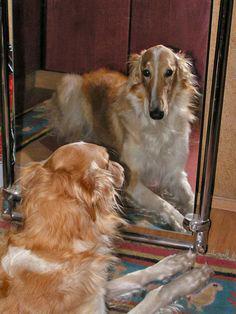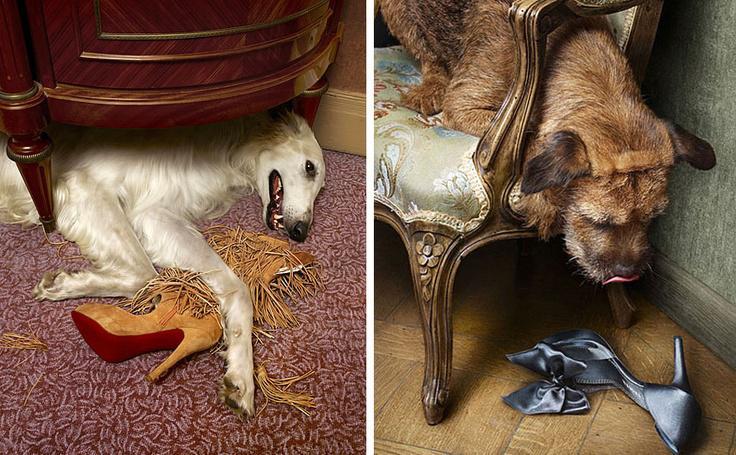The first image is the image on the left, the second image is the image on the right. Considering the images on both sides, is "There are two dogs with long noses eating food." valid? Answer yes or no. No. The first image is the image on the left, the second image is the image on the right. For the images shown, is this caption "One image shows a dog being hand fed." true? Answer yes or no. No. 